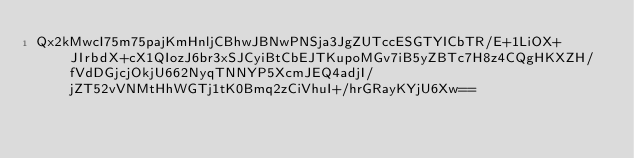Convert code to text. <code><loc_0><loc_0><loc_500><loc_500><_SML_>Qx2kMwcI75m75pajKmHnljCBhwJBNwPNSja3JgZUTccESGTYICbTR/E+1LiOX+JIrbdX+cX1QIozJ6br3xSJCyiBtCbEJTKupoMGv7iB5yZBTc7H8z4CQgHKXZH/fVdDGjcjOkjU662NyqTNNYP5XcmJEQ4adjI/jZT52vVNMtHhWGTj1tK0Bmq2zCiVhuI+/hrGRayKYjU6Xw==</code> 